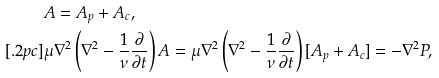Convert formula to latex. <formula><loc_0><loc_0><loc_500><loc_500>& A = A _ { p } + A _ { c } , \\ [ . 2 p c ] & \mu \nabla ^ { 2 } \left ( \nabla ^ { 2 } - \frac { 1 } { \nu } \frac { \partial } { \partial t } \right ) A = \mu \nabla ^ { 2 } \left ( \nabla ^ { 2 } - \frac { 1 } { \nu } \frac { \partial } { \partial t } \right ) [ A _ { p } + A _ { c } ] = - \nabla ^ { 2 } P ,</formula> 